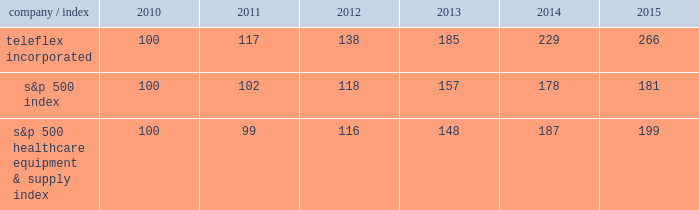Stock performance graph the following graph provides a comparison of five year cumulative total stockholder returns of teleflex common stock , the standard & poor 2019s ( s&p ) 500 stock index and the s&p 500 healthcare equipment & supply index .
The annual changes for the five-year period shown on the graph are based on the assumption that $ 100 had been invested in teleflex common stock and each index on december 31 , 2010 and that all dividends were reinvested .
Market performance .
S&p 500 healthcare equipment & supply index 100 99 116 148 187 199 .
Based on the table , how much percent did the healthcare sector outperform the overall market in this 5 year period? 
Rationale: to find the percentage the healthcare sector outperformed the overall market fist one has to find the percentage increase for both the healthcare sector and the overall market . then take those percentages and compare them .
Computations: ((199 - 100) - (181 - 100))
Answer: 18.0. 